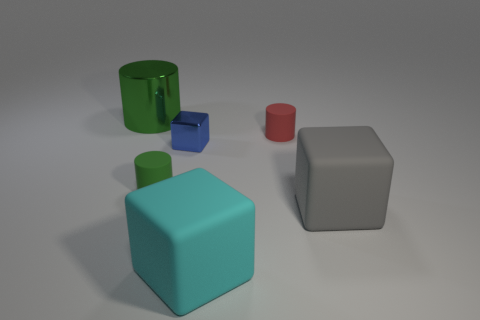There is a tiny cylinder that is the same color as the big cylinder; what material is it?
Provide a succinct answer. Rubber. The other cylinder that is the same color as the large shiny cylinder is what size?
Ensure brevity in your answer.  Small. What is the shape of the large matte object that is on the right side of the cyan thing?
Your answer should be compact. Cube. Do the big cyan matte object and the big thing that is left of the cyan thing have the same shape?
Offer a terse response. No. There is a thing that is both to the left of the large cyan matte object and in front of the blue cube; what size is it?
Keep it short and to the point. Small. What color is the cylinder that is to the left of the tiny red rubber cylinder and behind the green rubber object?
Offer a very short reply. Green. Is there any other thing that is the same material as the cyan cube?
Provide a short and direct response. Yes. Is the number of tiny green matte objects on the right side of the gray thing less than the number of large matte blocks right of the tiny red thing?
Offer a very short reply. Yes. Is there anything else that has the same color as the shiny cylinder?
Make the answer very short. Yes. What is the shape of the red thing?
Ensure brevity in your answer.  Cylinder. 